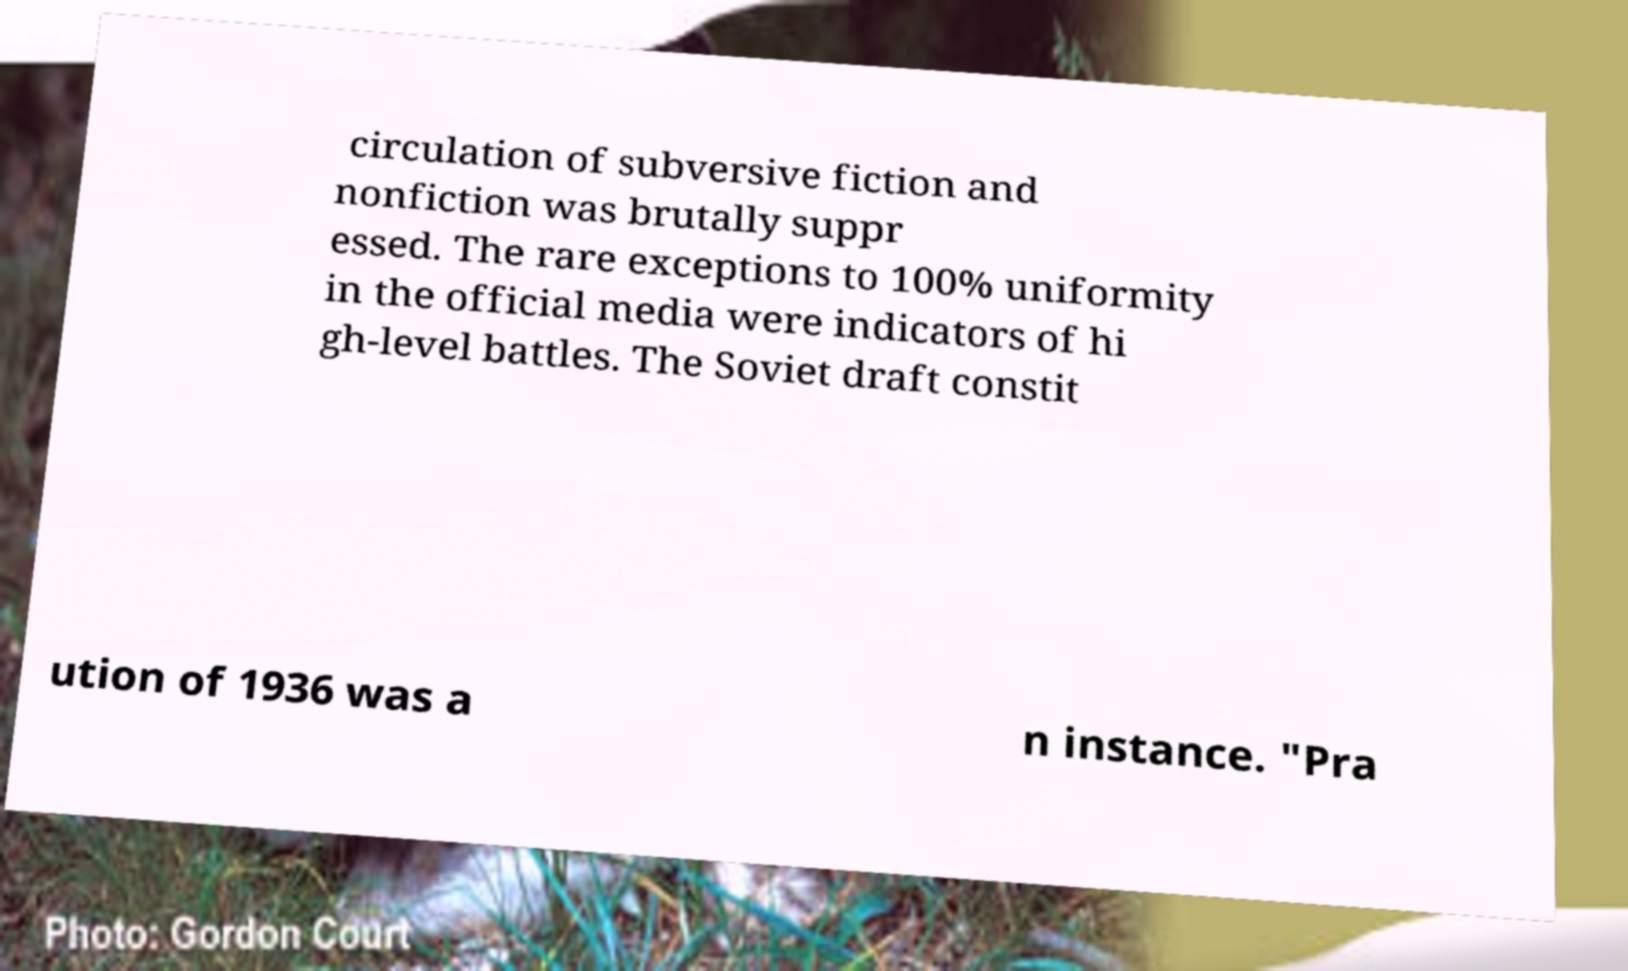There's text embedded in this image that I need extracted. Can you transcribe it verbatim? circulation of subversive fiction and nonfiction was brutally suppr essed. The rare exceptions to 100% uniformity in the official media were indicators of hi gh-level battles. The Soviet draft constit ution of 1936 was a n instance. "Pra 